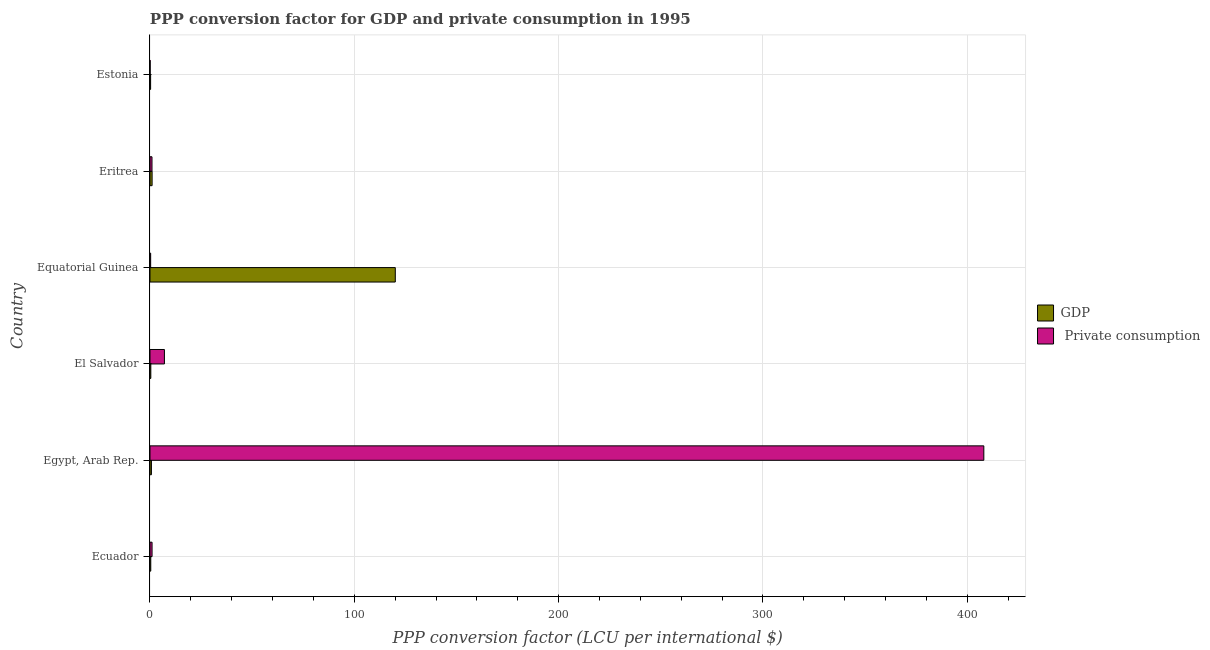How many groups of bars are there?
Ensure brevity in your answer.  6. Are the number of bars on each tick of the Y-axis equal?
Your answer should be very brief. Yes. How many bars are there on the 5th tick from the bottom?
Make the answer very short. 2. What is the label of the 3rd group of bars from the top?
Your answer should be compact. Equatorial Guinea. In how many cases, is the number of bars for a given country not equal to the number of legend labels?
Keep it short and to the point. 0. What is the ppp conversion factor for private consumption in Equatorial Guinea?
Your answer should be very brief. 0.33. Across all countries, what is the maximum ppp conversion factor for private consumption?
Make the answer very short. 408.12. Across all countries, what is the minimum ppp conversion factor for gdp?
Ensure brevity in your answer.  0.3. In which country was the ppp conversion factor for private consumption maximum?
Offer a terse response. Egypt, Arab Rep. In which country was the ppp conversion factor for private consumption minimum?
Provide a succinct answer. Estonia. What is the total ppp conversion factor for private consumption in the graph?
Offer a terse response. 417.58. What is the difference between the ppp conversion factor for private consumption in Eritrea and that in Estonia?
Give a very brief answer. 0.91. What is the difference between the ppp conversion factor for gdp in Ecuador and the ppp conversion factor for private consumption in Egypt, Arab Rep.?
Offer a terse response. -407.74. What is the average ppp conversion factor for private consumption per country?
Your response must be concise. 69.6. What is the difference between the ppp conversion factor for private consumption and ppp conversion factor for gdp in Ecuador?
Provide a succinct answer. 0.64. In how many countries, is the ppp conversion factor for private consumption greater than 140 LCU?
Your answer should be compact. 1. What is the ratio of the ppp conversion factor for gdp in Ecuador to that in El Salvador?
Keep it short and to the point. 0.93. Is the difference between the ppp conversion factor for private consumption in Egypt, Arab Rep. and Equatorial Guinea greater than the difference between the ppp conversion factor for gdp in Egypt, Arab Rep. and Equatorial Guinea?
Your answer should be compact. Yes. What is the difference between the highest and the second highest ppp conversion factor for private consumption?
Provide a short and direct response. 401.05. What is the difference between the highest and the lowest ppp conversion factor for gdp?
Provide a succinct answer. 119.76. What does the 2nd bar from the top in El Salvador represents?
Your answer should be very brief. GDP. What does the 2nd bar from the bottom in Eritrea represents?
Your answer should be very brief.  Private consumption. What is the difference between two consecutive major ticks on the X-axis?
Offer a terse response. 100. Are the values on the major ticks of X-axis written in scientific E-notation?
Offer a terse response. No. Does the graph contain grids?
Your answer should be very brief. Yes. How many legend labels are there?
Give a very brief answer. 2. How are the legend labels stacked?
Your answer should be compact. Vertical. What is the title of the graph?
Your response must be concise. PPP conversion factor for GDP and private consumption in 1995. What is the label or title of the X-axis?
Keep it short and to the point. PPP conversion factor (LCU per international $). What is the label or title of the Y-axis?
Make the answer very short. Country. What is the PPP conversion factor (LCU per international $) in GDP in Ecuador?
Your answer should be very brief. 0.38. What is the PPP conversion factor (LCU per international $) of  Private consumption in Ecuador?
Your answer should be compact. 1.02. What is the PPP conversion factor (LCU per international $) in GDP in Egypt, Arab Rep.?
Offer a terse response. 0.7. What is the PPP conversion factor (LCU per international $) in  Private consumption in Egypt, Arab Rep.?
Keep it short and to the point. 408.12. What is the PPP conversion factor (LCU per international $) in GDP in El Salvador?
Provide a succinct answer. 0.41. What is the PPP conversion factor (LCU per international $) in  Private consumption in El Salvador?
Ensure brevity in your answer.  7.07. What is the PPP conversion factor (LCU per international $) in GDP in Equatorial Guinea?
Offer a terse response. 120.06. What is the PPP conversion factor (LCU per international $) in  Private consumption in Equatorial Guinea?
Give a very brief answer. 0.33. What is the PPP conversion factor (LCU per international $) in GDP in Eritrea?
Ensure brevity in your answer.  1.04. What is the PPP conversion factor (LCU per international $) in  Private consumption in Eritrea?
Your answer should be compact. 0.98. What is the PPP conversion factor (LCU per international $) of GDP in Estonia?
Ensure brevity in your answer.  0.3. What is the PPP conversion factor (LCU per international $) of  Private consumption in Estonia?
Offer a terse response. 0.07. Across all countries, what is the maximum PPP conversion factor (LCU per international $) of GDP?
Provide a succinct answer. 120.06. Across all countries, what is the maximum PPP conversion factor (LCU per international $) in  Private consumption?
Your answer should be compact. 408.12. Across all countries, what is the minimum PPP conversion factor (LCU per international $) of GDP?
Give a very brief answer. 0.3. Across all countries, what is the minimum PPP conversion factor (LCU per international $) of  Private consumption?
Provide a succinct answer. 0.07. What is the total PPP conversion factor (LCU per international $) of GDP in the graph?
Offer a terse response. 122.88. What is the total PPP conversion factor (LCU per international $) in  Private consumption in the graph?
Ensure brevity in your answer.  417.58. What is the difference between the PPP conversion factor (LCU per international $) of GDP in Ecuador and that in Egypt, Arab Rep.?
Your answer should be very brief. -0.32. What is the difference between the PPP conversion factor (LCU per international $) of  Private consumption in Ecuador and that in Egypt, Arab Rep.?
Make the answer very short. -407.1. What is the difference between the PPP conversion factor (LCU per international $) of GDP in Ecuador and that in El Salvador?
Your response must be concise. -0.03. What is the difference between the PPP conversion factor (LCU per international $) of  Private consumption in Ecuador and that in El Salvador?
Ensure brevity in your answer.  -6.05. What is the difference between the PPP conversion factor (LCU per international $) in GDP in Ecuador and that in Equatorial Guinea?
Offer a terse response. -119.68. What is the difference between the PPP conversion factor (LCU per international $) in  Private consumption in Ecuador and that in Equatorial Guinea?
Your response must be concise. 0.69. What is the difference between the PPP conversion factor (LCU per international $) of GDP in Ecuador and that in Eritrea?
Ensure brevity in your answer.  -0.66. What is the difference between the PPP conversion factor (LCU per international $) of  Private consumption in Ecuador and that in Eritrea?
Offer a terse response. 0.04. What is the difference between the PPP conversion factor (LCU per international $) of GDP in Ecuador and that in Estonia?
Give a very brief answer. 0.07. What is the difference between the PPP conversion factor (LCU per international $) of  Private consumption in Ecuador and that in Estonia?
Offer a very short reply. 0.94. What is the difference between the PPP conversion factor (LCU per international $) of GDP in Egypt, Arab Rep. and that in El Salvador?
Give a very brief answer. 0.29. What is the difference between the PPP conversion factor (LCU per international $) in  Private consumption in Egypt, Arab Rep. and that in El Salvador?
Provide a short and direct response. 401.05. What is the difference between the PPP conversion factor (LCU per international $) of GDP in Egypt, Arab Rep. and that in Equatorial Guinea?
Give a very brief answer. -119.36. What is the difference between the PPP conversion factor (LCU per international $) of  Private consumption in Egypt, Arab Rep. and that in Equatorial Guinea?
Your response must be concise. 407.79. What is the difference between the PPP conversion factor (LCU per international $) of GDP in Egypt, Arab Rep. and that in Eritrea?
Give a very brief answer. -0.34. What is the difference between the PPP conversion factor (LCU per international $) of  Private consumption in Egypt, Arab Rep. and that in Eritrea?
Keep it short and to the point. 407.14. What is the difference between the PPP conversion factor (LCU per international $) in GDP in Egypt, Arab Rep. and that in Estonia?
Make the answer very short. 0.39. What is the difference between the PPP conversion factor (LCU per international $) in  Private consumption in Egypt, Arab Rep. and that in Estonia?
Offer a terse response. 408.04. What is the difference between the PPP conversion factor (LCU per international $) in GDP in El Salvador and that in Equatorial Guinea?
Your answer should be compact. -119.66. What is the difference between the PPP conversion factor (LCU per international $) in  Private consumption in El Salvador and that in Equatorial Guinea?
Your response must be concise. 6.74. What is the difference between the PPP conversion factor (LCU per international $) of GDP in El Salvador and that in Eritrea?
Offer a very short reply. -0.63. What is the difference between the PPP conversion factor (LCU per international $) of  Private consumption in El Salvador and that in Eritrea?
Give a very brief answer. 6.08. What is the difference between the PPP conversion factor (LCU per international $) of GDP in El Salvador and that in Estonia?
Ensure brevity in your answer.  0.1. What is the difference between the PPP conversion factor (LCU per international $) of  Private consumption in El Salvador and that in Estonia?
Your response must be concise. 6.99. What is the difference between the PPP conversion factor (LCU per international $) in GDP in Equatorial Guinea and that in Eritrea?
Your answer should be compact. 119.03. What is the difference between the PPP conversion factor (LCU per international $) in  Private consumption in Equatorial Guinea and that in Eritrea?
Your response must be concise. -0.65. What is the difference between the PPP conversion factor (LCU per international $) of GDP in Equatorial Guinea and that in Estonia?
Your answer should be compact. 119.76. What is the difference between the PPP conversion factor (LCU per international $) in  Private consumption in Equatorial Guinea and that in Estonia?
Your answer should be very brief. 0.25. What is the difference between the PPP conversion factor (LCU per international $) in GDP in Eritrea and that in Estonia?
Your response must be concise. 0.73. What is the difference between the PPP conversion factor (LCU per international $) of  Private consumption in Eritrea and that in Estonia?
Your answer should be compact. 0.91. What is the difference between the PPP conversion factor (LCU per international $) in GDP in Ecuador and the PPP conversion factor (LCU per international $) in  Private consumption in Egypt, Arab Rep.?
Give a very brief answer. -407.74. What is the difference between the PPP conversion factor (LCU per international $) in GDP in Ecuador and the PPP conversion factor (LCU per international $) in  Private consumption in El Salvador?
Give a very brief answer. -6.69. What is the difference between the PPP conversion factor (LCU per international $) in GDP in Ecuador and the PPP conversion factor (LCU per international $) in  Private consumption in Equatorial Guinea?
Your response must be concise. 0.05. What is the difference between the PPP conversion factor (LCU per international $) in GDP in Ecuador and the PPP conversion factor (LCU per international $) in  Private consumption in Eritrea?
Make the answer very short. -0.6. What is the difference between the PPP conversion factor (LCU per international $) in GDP in Ecuador and the PPP conversion factor (LCU per international $) in  Private consumption in Estonia?
Offer a terse response. 0.3. What is the difference between the PPP conversion factor (LCU per international $) in GDP in Egypt, Arab Rep. and the PPP conversion factor (LCU per international $) in  Private consumption in El Salvador?
Make the answer very short. -6.37. What is the difference between the PPP conversion factor (LCU per international $) of GDP in Egypt, Arab Rep. and the PPP conversion factor (LCU per international $) of  Private consumption in Equatorial Guinea?
Provide a succinct answer. 0.37. What is the difference between the PPP conversion factor (LCU per international $) in GDP in Egypt, Arab Rep. and the PPP conversion factor (LCU per international $) in  Private consumption in Eritrea?
Offer a terse response. -0.28. What is the difference between the PPP conversion factor (LCU per international $) of GDP in Egypt, Arab Rep. and the PPP conversion factor (LCU per international $) of  Private consumption in Estonia?
Offer a terse response. 0.62. What is the difference between the PPP conversion factor (LCU per international $) of GDP in El Salvador and the PPP conversion factor (LCU per international $) of  Private consumption in Equatorial Guinea?
Provide a succinct answer. 0.08. What is the difference between the PPP conversion factor (LCU per international $) in GDP in El Salvador and the PPP conversion factor (LCU per international $) in  Private consumption in Eritrea?
Offer a very short reply. -0.58. What is the difference between the PPP conversion factor (LCU per international $) of GDP in El Salvador and the PPP conversion factor (LCU per international $) of  Private consumption in Estonia?
Give a very brief answer. 0.33. What is the difference between the PPP conversion factor (LCU per international $) of GDP in Equatorial Guinea and the PPP conversion factor (LCU per international $) of  Private consumption in Eritrea?
Your answer should be very brief. 119.08. What is the difference between the PPP conversion factor (LCU per international $) in GDP in Equatorial Guinea and the PPP conversion factor (LCU per international $) in  Private consumption in Estonia?
Provide a short and direct response. 119.99. What is the difference between the PPP conversion factor (LCU per international $) of GDP in Eritrea and the PPP conversion factor (LCU per international $) of  Private consumption in Estonia?
Provide a succinct answer. 0.96. What is the average PPP conversion factor (LCU per international $) in GDP per country?
Ensure brevity in your answer.  20.48. What is the average PPP conversion factor (LCU per international $) of  Private consumption per country?
Your answer should be very brief. 69.6. What is the difference between the PPP conversion factor (LCU per international $) in GDP and PPP conversion factor (LCU per international $) in  Private consumption in Ecuador?
Your answer should be very brief. -0.64. What is the difference between the PPP conversion factor (LCU per international $) of GDP and PPP conversion factor (LCU per international $) of  Private consumption in Egypt, Arab Rep.?
Keep it short and to the point. -407.42. What is the difference between the PPP conversion factor (LCU per international $) in GDP and PPP conversion factor (LCU per international $) in  Private consumption in El Salvador?
Ensure brevity in your answer.  -6.66. What is the difference between the PPP conversion factor (LCU per international $) of GDP and PPP conversion factor (LCU per international $) of  Private consumption in Equatorial Guinea?
Ensure brevity in your answer.  119.73. What is the difference between the PPP conversion factor (LCU per international $) in GDP and PPP conversion factor (LCU per international $) in  Private consumption in Eritrea?
Provide a short and direct response. 0.05. What is the difference between the PPP conversion factor (LCU per international $) in GDP and PPP conversion factor (LCU per international $) in  Private consumption in Estonia?
Keep it short and to the point. 0.23. What is the ratio of the PPP conversion factor (LCU per international $) of GDP in Ecuador to that in Egypt, Arab Rep.?
Provide a succinct answer. 0.54. What is the ratio of the PPP conversion factor (LCU per international $) of  Private consumption in Ecuador to that in Egypt, Arab Rep.?
Your response must be concise. 0. What is the ratio of the PPP conversion factor (LCU per international $) of GDP in Ecuador to that in El Salvador?
Ensure brevity in your answer.  0.93. What is the ratio of the PPP conversion factor (LCU per international $) in  Private consumption in Ecuador to that in El Salvador?
Make the answer very short. 0.14. What is the ratio of the PPP conversion factor (LCU per international $) in GDP in Ecuador to that in Equatorial Guinea?
Offer a very short reply. 0. What is the ratio of the PPP conversion factor (LCU per international $) of  Private consumption in Ecuador to that in Equatorial Guinea?
Your response must be concise. 3.1. What is the ratio of the PPP conversion factor (LCU per international $) in GDP in Ecuador to that in Eritrea?
Keep it short and to the point. 0.37. What is the ratio of the PPP conversion factor (LCU per international $) in  Private consumption in Ecuador to that in Eritrea?
Offer a very short reply. 1.04. What is the ratio of the PPP conversion factor (LCU per international $) of GDP in Ecuador to that in Estonia?
Give a very brief answer. 1.25. What is the ratio of the PPP conversion factor (LCU per international $) of  Private consumption in Ecuador to that in Estonia?
Provide a succinct answer. 13.6. What is the ratio of the PPP conversion factor (LCU per international $) of GDP in Egypt, Arab Rep. to that in El Salvador?
Keep it short and to the point. 1.72. What is the ratio of the PPP conversion factor (LCU per international $) of  Private consumption in Egypt, Arab Rep. to that in El Salvador?
Your answer should be compact. 57.75. What is the ratio of the PPP conversion factor (LCU per international $) of GDP in Egypt, Arab Rep. to that in Equatorial Guinea?
Offer a very short reply. 0.01. What is the ratio of the PPP conversion factor (LCU per international $) in  Private consumption in Egypt, Arab Rep. to that in Equatorial Guinea?
Give a very brief answer. 1244.63. What is the ratio of the PPP conversion factor (LCU per international $) in GDP in Egypt, Arab Rep. to that in Eritrea?
Your answer should be very brief. 0.67. What is the ratio of the PPP conversion factor (LCU per international $) in  Private consumption in Egypt, Arab Rep. to that in Eritrea?
Give a very brief answer. 415.73. What is the ratio of the PPP conversion factor (LCU per international $) in GDP in Egypt, Arab Rep. to that in Estonia?
Keep it short and to the point. 2.29. What is the ratio of the PPP conversion factor (LCU per international $) of  Private consumption in Egypt, Arab Rep. to that in Estonia?
Your response must be concise. 5461.09. What is the ratio of the PPP conversion factor (LCU per international $) in GDP in El Salvador to that in Equatorial Guinea?
Keep it short and to the point. 0. What is the ratio of the PPP conversion factor (LCU per international $) in  Private consumption in El Salvador to that in Equatorial Guinea?
Keep it short and to the point. 21.55. What is the ratio of the PPP conversion factor (LCU per international $) of GDP in El Salvador to that in Eritrea?
Your answer should be compact. 0.39. What is the ratio of the PPP conversion factor (LCU per international $) of  Private consumption in El Salvador to that in Eritrea?
Offer a terse response. 7.2. What is the ratio of the PPP conversion factor (LCU per international $) in GDP in El Salvador to that in Estonia?
Your answer should be compact. 1.33. What is the ratio of the PPP conversion factor (LCU per international $) in  Private consumption in El Salvador to that in Estonia?
Give a very brief answer. 94.56. What is the ratio of the PPP conversion factor (LCU per international $) in GDP in Equatorial Guinea to that in Eritrea?
Make the answer very short. 115.98. What is the ratio of the PPP conversion factor (LCU per international $) in  Private consumption in Equatorial Guinea to that in Eritrea?
Give a very brief answer. 0.33. What is the ratio of the PPP conversion factor (LCU per international $) in GDP in Equatorial Guinea to that in Estonia?
Your answer should be very brief. 394.66. What is the ratio of the PPP conversion factor (LCU per international $) of  Private consumption in Equatorial Guinea to that in Estonia?
Make the answer very short. 4.39. What is the ratio of the PPP conversion factor (LCU per international $) in GDP in Eritrea to that in Estonia?
Offer a very short reply. 3.4. What is the ratio of the PPP conversion factor (LCU per international $) of  Private consumption in Eritrea to that in Estonia?
Keep it short and to the point. 13.14. What is the difference between the highest and the second highest PPP conversion factor (LCU per international $) of GDP?
Make the answer very short. 119.03. What is the difference between the highest and the second highest PPP conversion factor (LCU per international $) of  Private consumption?
Offer a very short reply. 401.05. What is the difference between the highest and the lowest PPP conversion factor (LCU per international $) in GDP?
Provide a short and direct response. 119.76. What is the difference between the highest and the lowest PPP conversion factor (LCU per international $) of  Private consumption?
Offer a terse response. 408.04. 